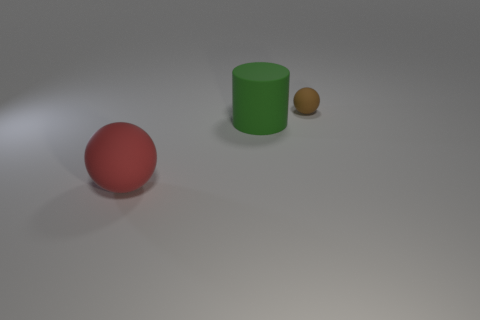Subtract all red balls. How many balls are left? 1 Subtract all cylinders. How many objects are left? 2 Subtract all cyan cylinders. How many red spheres are left? 1 Add 1 big green matte cylinders. How many big green matte cylinders are left? 2 Add 2 large red metal things. How many large red metal things exist? 2 Add 3 yellow rubber balls. How many objects exist? 6 Subtract 0 gray cylinders. How many objects are left? 3 Subtract all blue balls. Subtract all purple blocks. How many balls are left? 2 Subtract all green rubber things. Subtract all small cyan rubber cylinders. How many objects are left? 2 